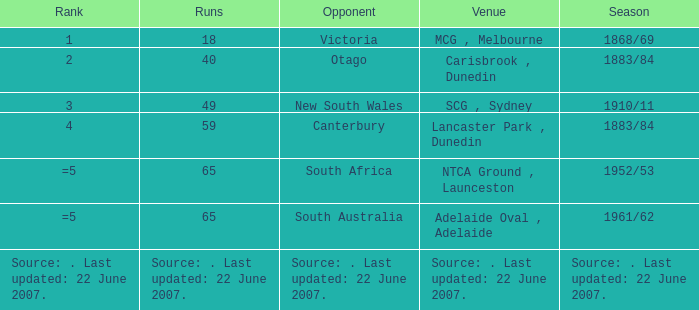Which Run has an Opponent of Canterbury? 59.0. 